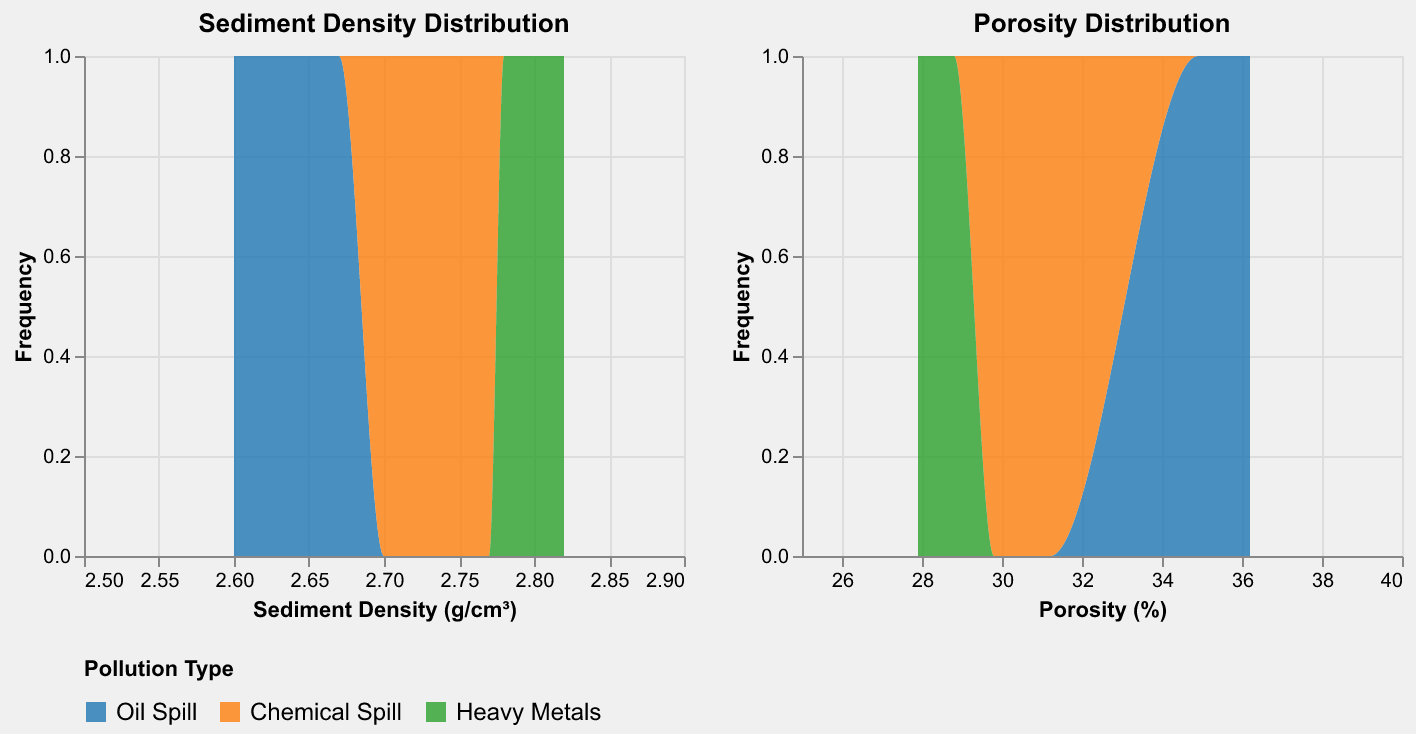What is the title of the figure showing the porosity distribution? The title of the second plot in the figure states what it represents.
Answer: Porosity Distribution What are the color representations for the different pollution types? The legend at the bottom of the figure shows the colors representing each pollution type. Oil Spill is blue, Chemical Spill is orange, and Heavy Metals is green.
Answer: Oil Spill: Blue, Chemical Spill: Orange, Heavy Metals: Green Which pollution type has the highest frequency of sediment density values between 2.60 and 2.70 g/cm³? By examining the Sediment Density Distribution plot, the blue color representing Oil Spill has the highest area under the curve in this range.
Answer: Oil Spill How do the average porosity percentages compare across the three pollution types? To compare the average porosity percentages, observe the peaks' positions in the Porosity Distribution plot for each pollution type. Chemical Spills show lower average porosity than Oil Spills, followed by Heavy Metals.
Answer: Chemical Spill < Oil Spill < Heavy Metals Which pollution type has the narrowest range of sediment density values? The Sediment Density Distribution plot shows the spread of each color. Heavy Metals, represented by green, appear to have the narrowest range of densities.
Answer: Heavy Metals Compare the porosities between 25% and 30% for the different pollution types. Which one shows the highest frequency? The Porosity Distribution plot reveals that the green area representing Heavy Metals is highest within the 25%-30% range.
Answer: Heavy Metals What can you infer about the relationship between sediment density and porosity for Oil Spills and Heavy Metals? Based on both plots, Oil Spill sites show higher porosity with lower density, while Heavy Metals sites have lower porosity with higher density. This inverse relationship can be inferred by examining the peak positions.
Answer: Oil Spill: higher porosity, lower density; Heavy Metals: lower porosity, higher density Which pollution type has more uniformly distributed porosity values? By observing the Porosity Distribution plot, the blue area for Oil Spill appears more widely spread and uniform compared to the others.
Answer: Oil Spill Which pollution type appears to have the most samples based on the sediment density plot? The Sediment Density Distribution plot shows that the blue area for Oil Spill covers a wider range and has more area compared to other pollution types.
Answer: Oil Spill 